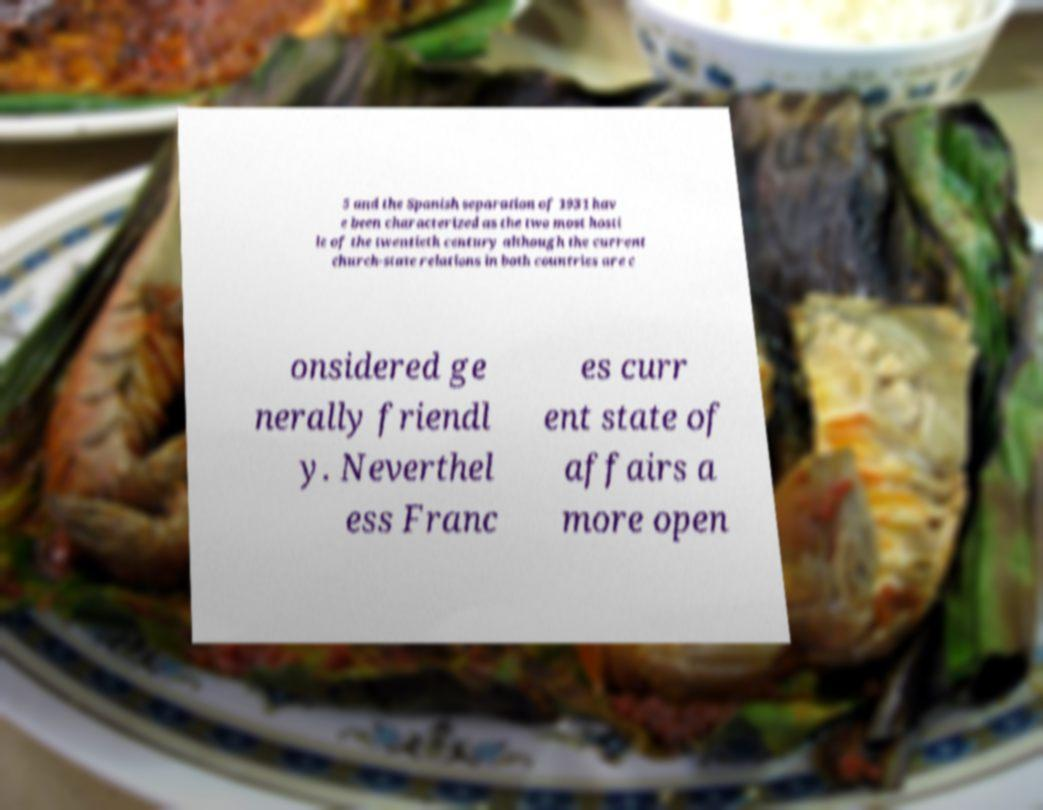Please identify and transcribe the text found in this image. 5 and the Spanish separation of 1931 hav e been characterized as the two most hosti le of the twentieth century although the current church-state relations in both countries are c onsidered ge nerally friendl y. Neverthel ess Franc es curr ent state of affairs a more open 